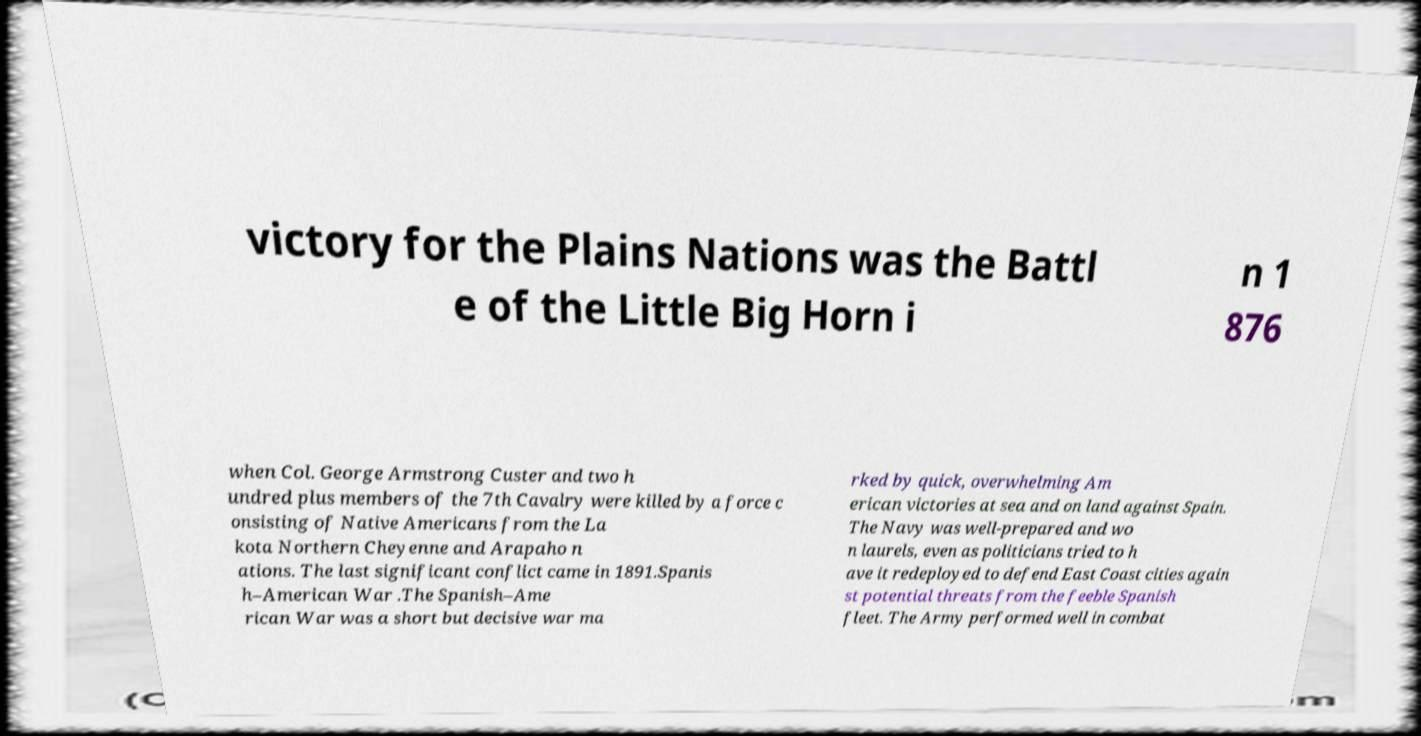Could you extract and type out the text from this image? victory for the Plains Nations was the Battl e of the Little Big Horn i n 1 876 when Col. George Armstrong Custer and two h undred plus members of the 7th Cavalry were killed by a force c onsisting of Native Americans from the La kota Northern Cheyenne and Arapaho n ations. The last significant conflict came in 1891.Spanis h–American War .The Spanish–Ame rican War was a short but decisive war ma rked by quick, overwhelming Am erican victories at sea and on land against Spain. The Navy was well-prepared and wo n laurels, even as politicians tried to h ave it redeployed to defend East Coast cities again st potential threats from the feeble Spanish fleet. The Army performed well in combat 